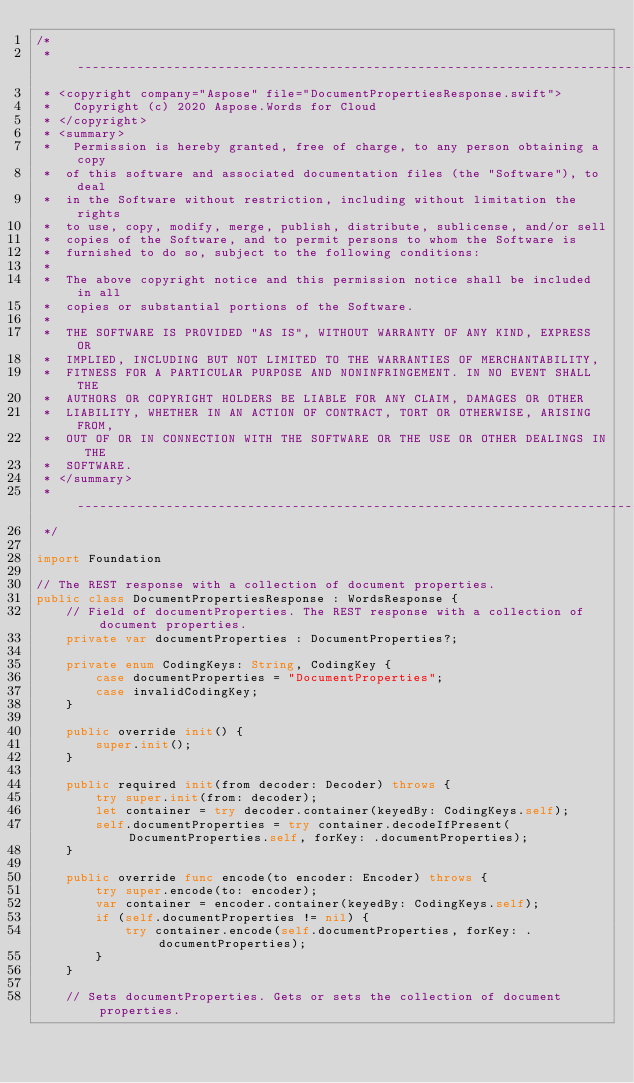Convert code to text. <code><loc_0><loc_0><loc_500><loc_500><_Swift_>/*
 * --------------------------------------------------------------------------------
 * <copyright company="Aspose" file="DocumentPropertiesResponse.swift">
 *   Copyright (c) 2020 Aspose.Words for Cloud
 * </copyright>
 * <summary>
 *   Permission is hereby granted, free of charge, to any person obtaining a copy
 *  of this software and associated documentation files (the "Software"), to deal
 *  in the Software without restriction, including without limitation the rights
 *  to use, copy, modify, merge, publish, distribute, sublicense, and/or sell
 *  copies of the Software, and to permit persons to whom the Software is
 *  furnished to do so, subject to the following conditions:
 * 
 *  The above copyright notice and this permission notice shall be included in all
 *  copies or substantial portions of the Software.
 * 
 *  THE SOFTWARE IS PROVIDED "AS IS", WITHOUT WARRANTY OF ANY KIND, EXPRESS OR
 *  IMPLIED, INCLUDING BUT NOT LIMITED TO THE WARRANTIES OF MERCHANTABILITY,
 *  FITNESS FOR A PARTICULAR PURPOSE AND NONINFRINGEMENT. IN NO EVENT SHALL THE
 *  AUTHORS OR COPYRIGHT HOLDERS BE LIABLE FOR ANY CLAIM, DAMAGES OR OTHER
 *  LIABILITY, WHETHER IN AN ACTION OF CONTRACT, TORT OR OTHERWISE, ARISING FROM,
 *  OUT OF OR IN CONNECTION WITH THE SOFTWARE OR THE USE OR OTHER DEALINGS IN THE
 *  SOFTWARE.
 * </summary>
 * --------------------------------------------------------------------------------
 */

import Foundation

// The REST response with a collection of document properties.
public class DocumentPropertiesResponse : WordsResponse {
    // Field of documentProperties. The REST response with a collection of document properties.
    private var documentProperties : DocumentProperties?;

    private enum CodingKeys: String, CodingKey {
        case documentProperties = "DocumentProperties";
        case invalidCodingKey;
    }

    public override init() {
        super.init();
    }

    public required init(from decoder: Decoder) throws {
        try super.init(from: decoder);
        let container = try decoder.container(keyedBy: CodingKeys.self);
        self.documentProperties = try container.decodeIfPresent(DocumentProperties.self, forKey: .documentProperties);
    }

    public override func encode(to encoder: Encoder) throws {
        try super.encode(to: encoder);
        var container = encoder.container(keyedBy: CodingKeys.self);
        if (self.documentProperties != nil) {
            try container.encode(self.documentProperties, forKey: .documentProperties);
        }
    }

    // Sets documentProperties. Gets or sets the collection of document properties.</code> 